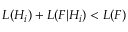Convert formula to latex. <formula><loc_0><loc_0><loc_500><loc_500>L ( H _ { i } ) + L ( F | H _ { i } ) < L ( F )</formula> 